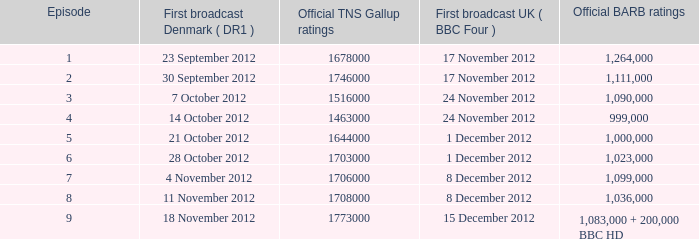I'm looking to parse the entire table for insights. Could you assist me with that? {'header': ['Episode', 'First broadcast Denmark ( DR1 )', 'Official TNS Gallup ratings', 'First broadcast UK ( BBC Four )', 'Official BARB ratings'], 'rows': [['1', '23 September 2012', '1678000', '17 November 2012', '1,264,000'], ['2', '30 September 2012', '1746000', '17 November 2012', '1,111,000'], ['3', '7 October 2012', '1516000', '24 November 2012', '1,090,000'], ['4', '14 October 2012', '1463000', '24 November 2012', '999,000'], ['5', '21 October 2012', '1644000', '1 December 2012', '1,000,000'], ['6', '28 October 2012', '1703000', '1 December 2012', '1,023,000'], ['7', '4 November 2012', '1706000', '8 December 2012', '1,099,000'], ['8', '11 November 2012', '1708000', '8 December 2012', '1,036,000'], ['9', '18 November 2012', '1773000', '15 December 2012', '1,083,000 + 200,000 BBC HD']]} What are the barb rankings for episode 6? 1023000.0. 